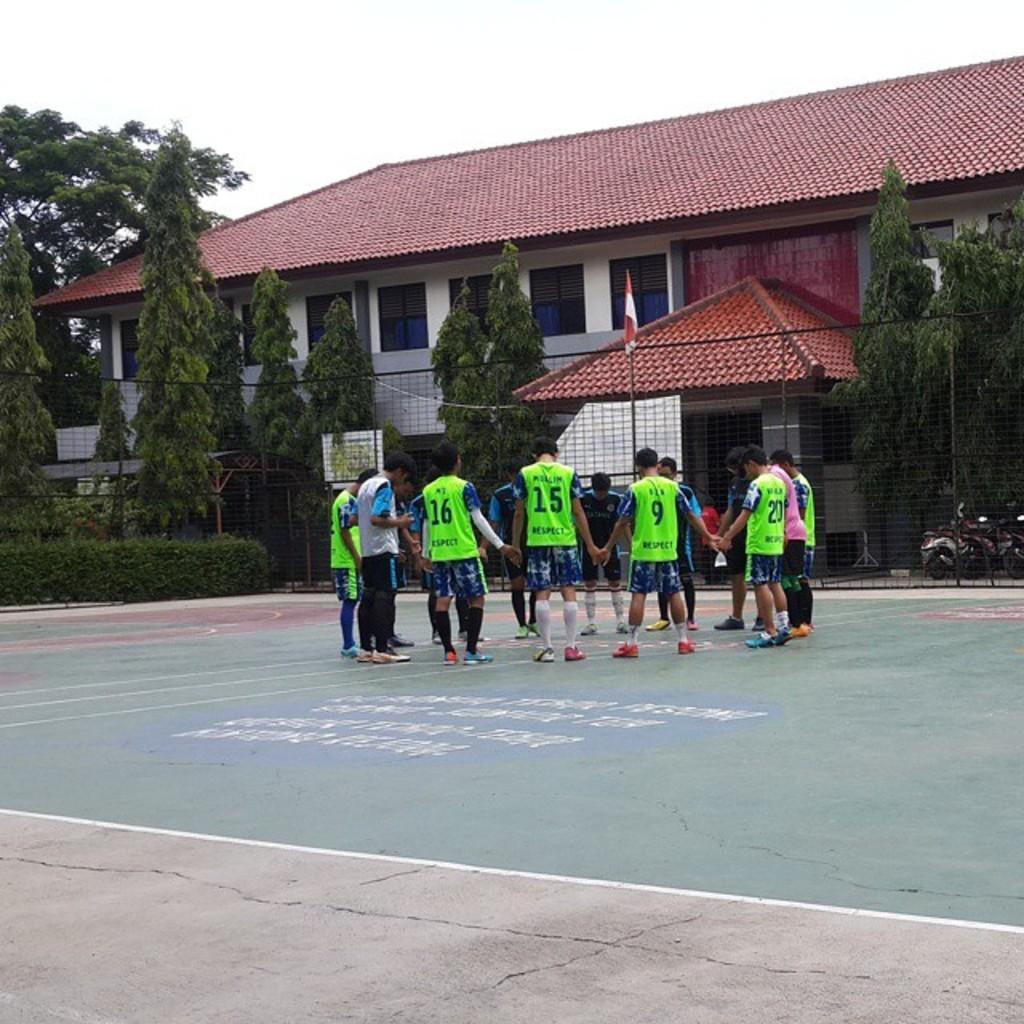Could you give a brief overview of what you see in this image? In this image there are group of people standing together in ground, beside that there are so many trees and building. 